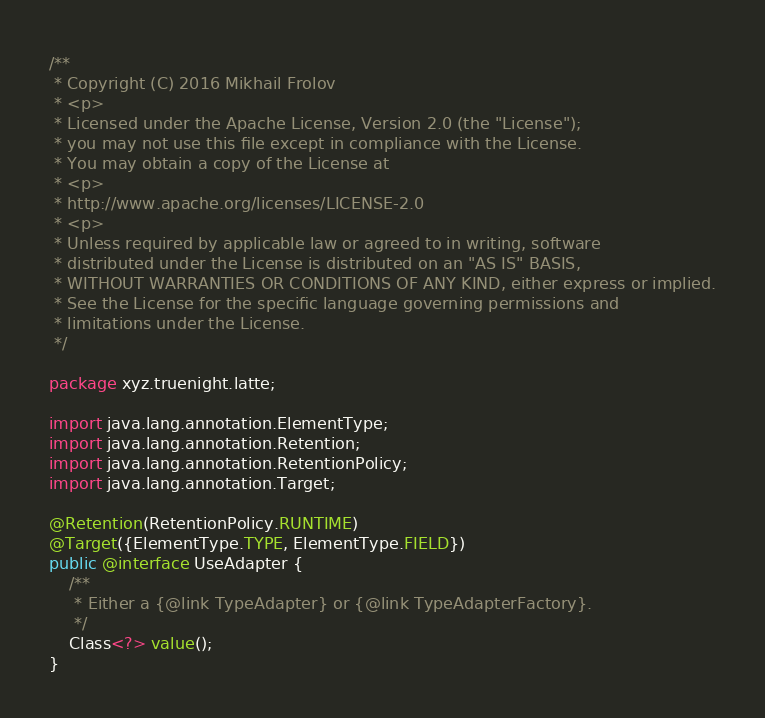Convert code to text. <code><loc_0><loc_0><loc_500><loc_500><_Java_>/**
 * Copyright (C) 2016 Mikhail Frolov
 * <p>
 * Licensed under the Apache License, Version 2.0 (the "License");
 * you may not use this file except in compliance with the License.
 * You may obtain a copy of the License at
 * <p>
 * http://www.apache.org/licenses/LICENSE-2.0
 * <p>
 * Unless required by applicable law or agreed to in writing, software
 * distributed under the License is distributed on an "AS IS" BASIS,
 * WITHOUT WARRANTIES OR CONDITIONS OF ANY KIND, either express or implied.
 * See the License for the specific language governing permissions and
 * limitations under the License.
 */

package xyz.truenight.latte;

import java.lang.annotation.ElementType;
import java.lang.annotation.Retention;
import java.lang.annotation.RetentionPolicy;
import java.lang.annotation.Target;

@Retention(RetentionPolicy.RUNTIME)
@Target({ElementType.TYPE, ElementType.FIELD})
public @interface UseAdapter {
    /**
     * Either a {@link TypeAdapter} or {@link TypeAdapterFactory}.
     */
    Class<?> value();
}
</code> 